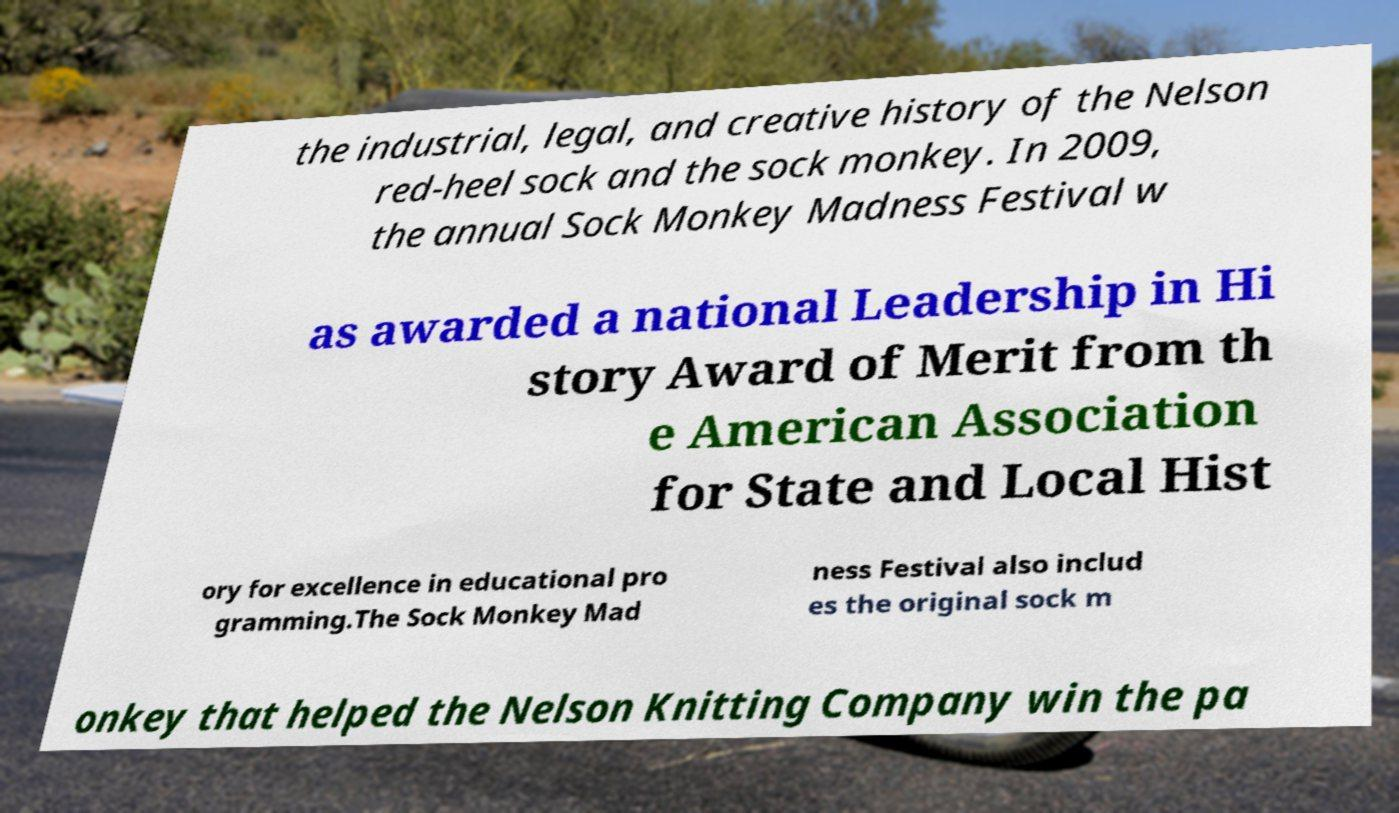Could you extract and type out the text from this image? the industrial, legal, and creative history of the Nelson red-heel sock and the sock monkey. In 2009, the annual Sock Monkey Madness Festival w as awarded a national Leadership in Hi story Award of Merit from th e American Association for State and Local Hist ory for excellence in educational pro gramming.The Sock Monkey Mad ness Festival also includ es the original sock m onkey that helped the Nelson Knitting Company win the pa 